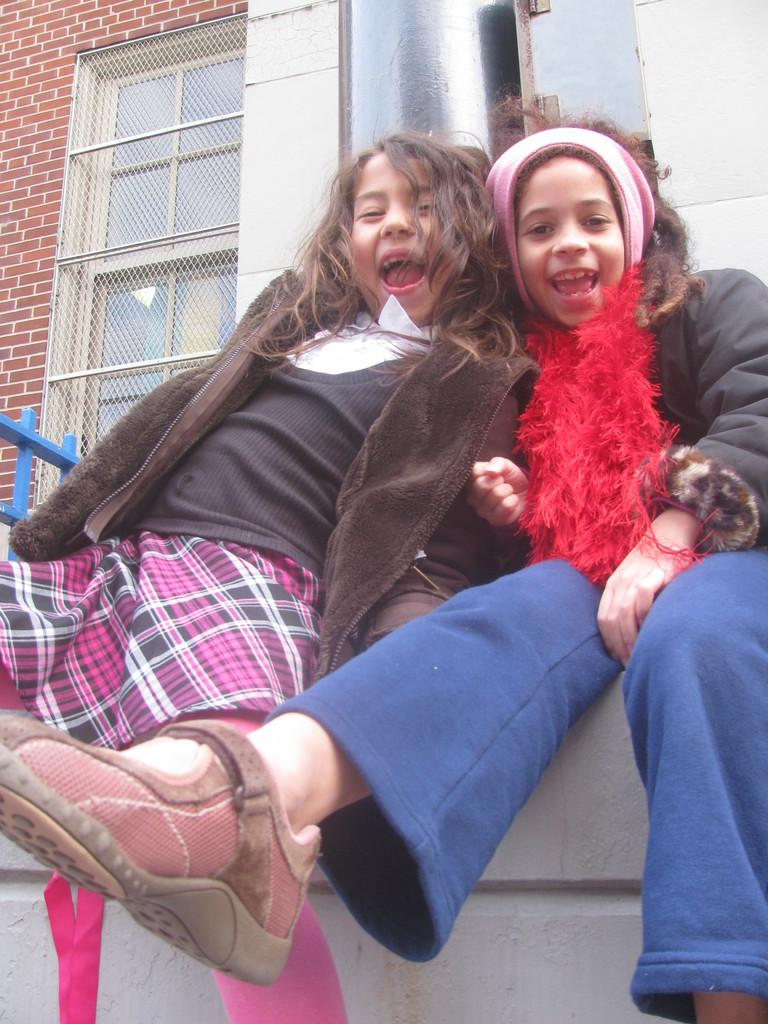How many people are in the image? There are two girls in the image. What expression do the girls have? The girls are smiling. What can be seen in the background of the image? There is a brick wall, a window, and other objects visible in the background of the image. What color is the heart that the girls are holding in the image? There is no heart present in the image; the girls are not holding any objects. 